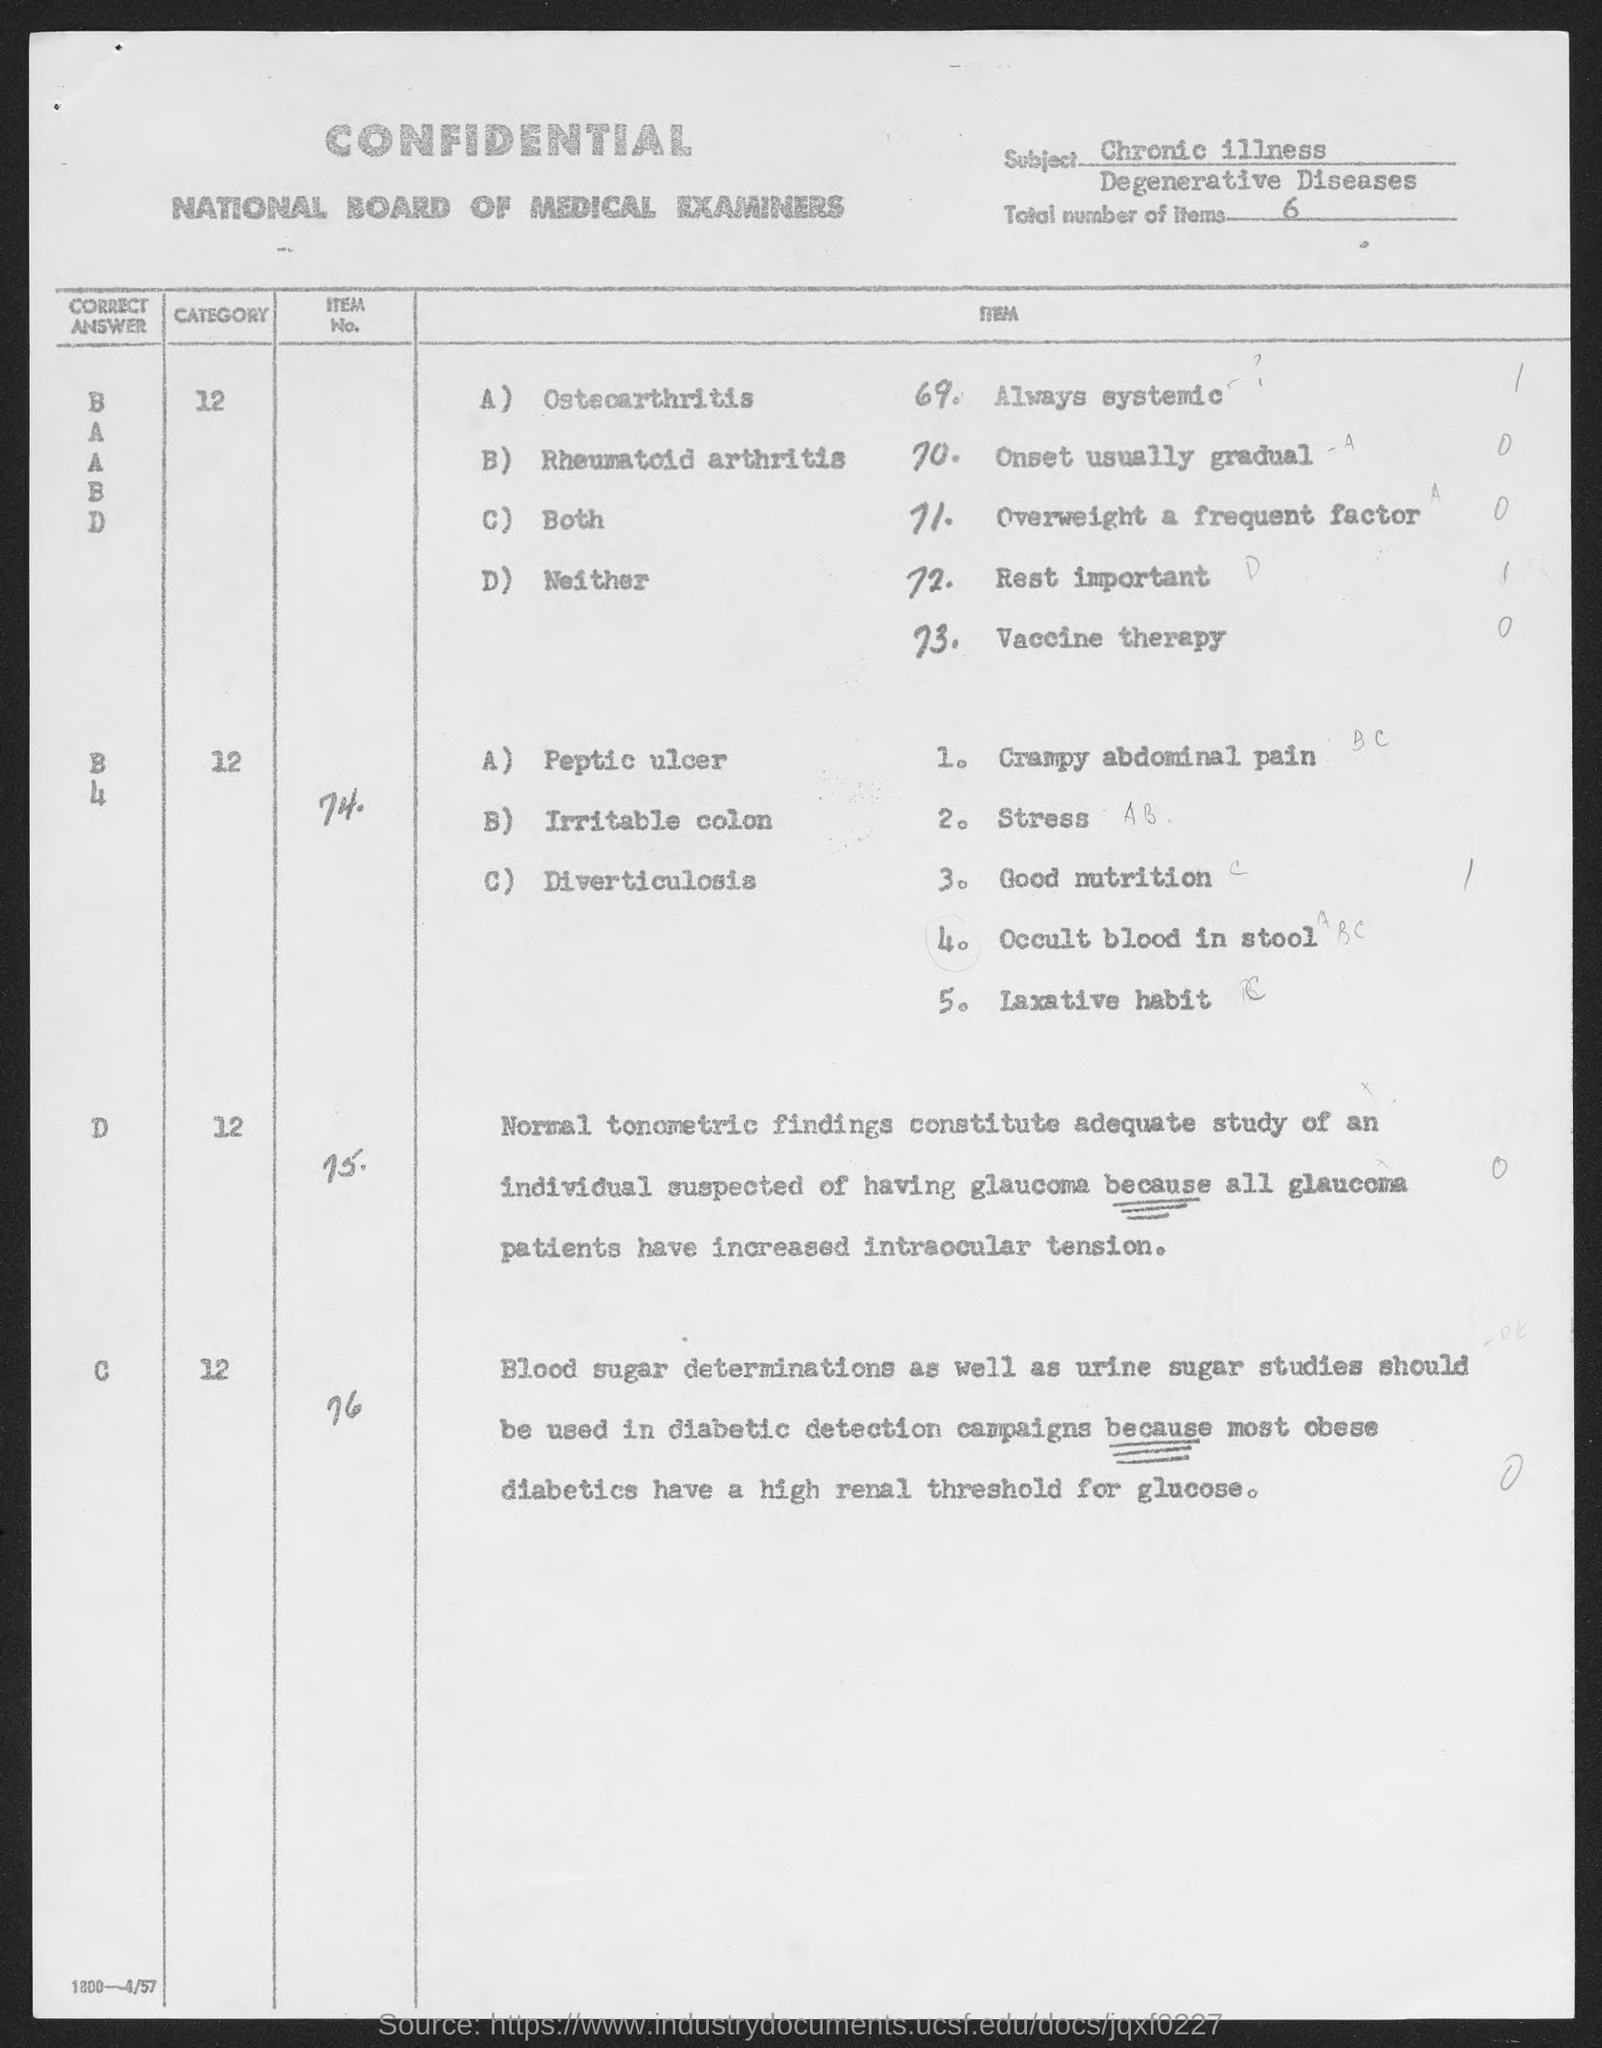What is the subject mentioned in the given page ?
Keep it short and to the point. Chronic illness Degenerative Diseases. What are the total no. of items mentioned in the given page ?
Make the answer very short. 6. 